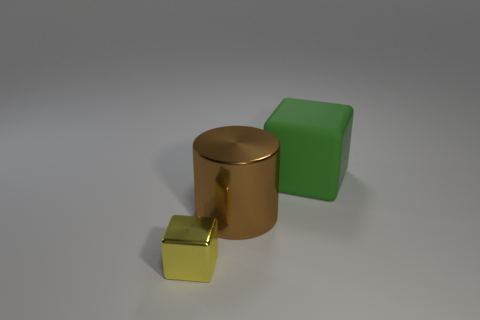Could you describe the lighting and shadows in this scene? The lighting in this scene is soft and diffused, emanating from the upper left, casting gentle shadows to the lower right of the objects. The shadows are soft-edged and elongated, indicating the light source is not too close to the objects. This type of lighting creates a calming and neutral atmosphere.  What can the arrangement of these objects tell us about the composition? The arrangement showcases a simple but effective composition. The objects are placed roughly in a diagonal line, which guides the eye across the image. The varying sizes of the objects create a visual hierarchy, with the largest at the back and the smallest at the front, adding depth to the scene. The choice of colors and materials also contrasts and complements each other, with the metallic sheen against the matte and reflective surfaces. 